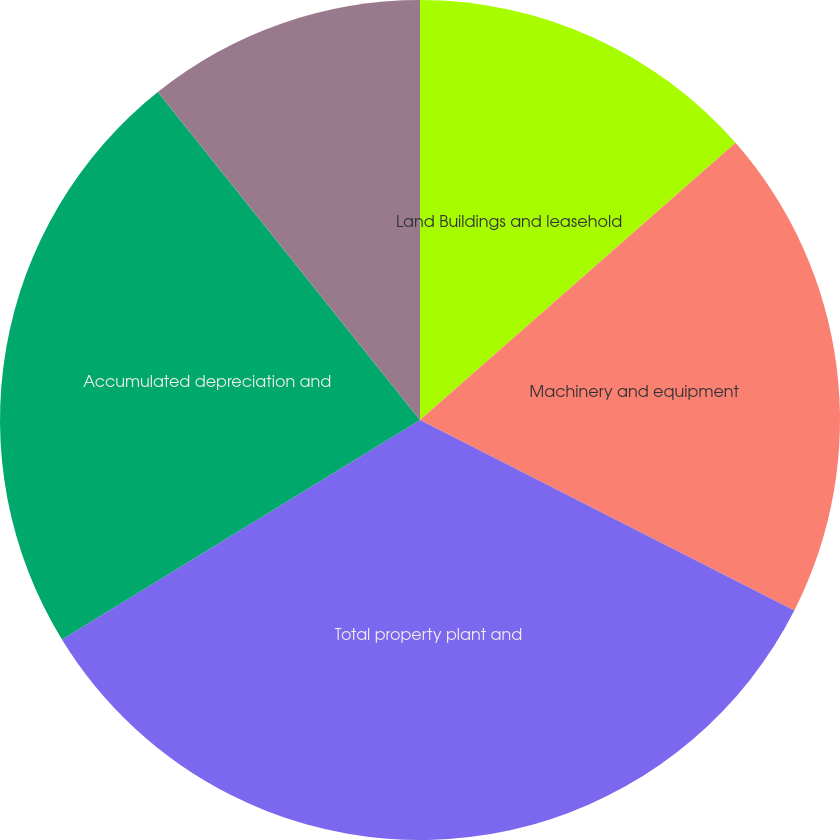Convert chart to OTSL. <chart><loc_0><loc_0><loc_500><loc_500><pie_chart><fcel>Land Buildings and leasehold<fcel>Machinery and equipment<fcel>Total property plant and<fcel>Accumulated depreciation and<fcel>Property plant and equipment<nl><fcel>13.53%<fcel>18.96%<fcel>33.75%<fcel>23.02%<fcel>10.73%<nl></chart> 